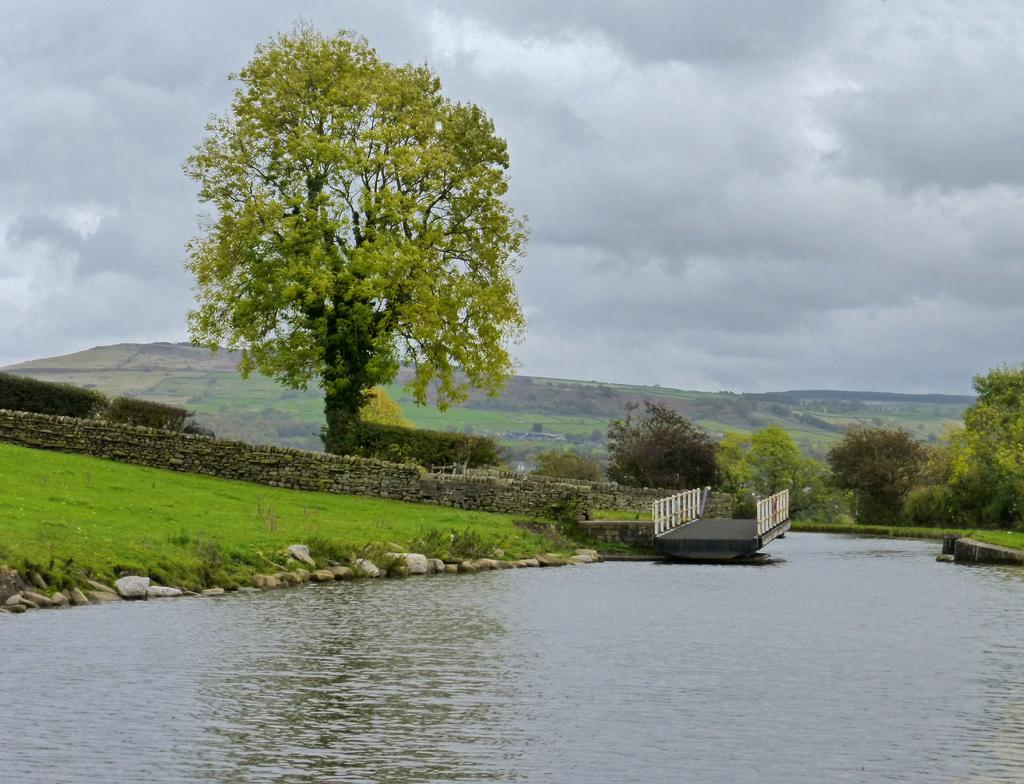What is the main feature of the image? The main feature of the image is water. What structures are near the water? There is a bridge near the water. What type of terrain is visible near the water? Rocks are present on the sides of the water. What type of vegetation can be seen in the image? Grass and trees are visible in the image. What type of landscape is present in the image? Hills are present in the image. What is visible in the sky? The sky is visible in the image, and clouds are present. What language is the pet using to communicate with the trees in the image? There is no pet present in the image, so it is not possible to determine what language they might use to communicate with the trees. 